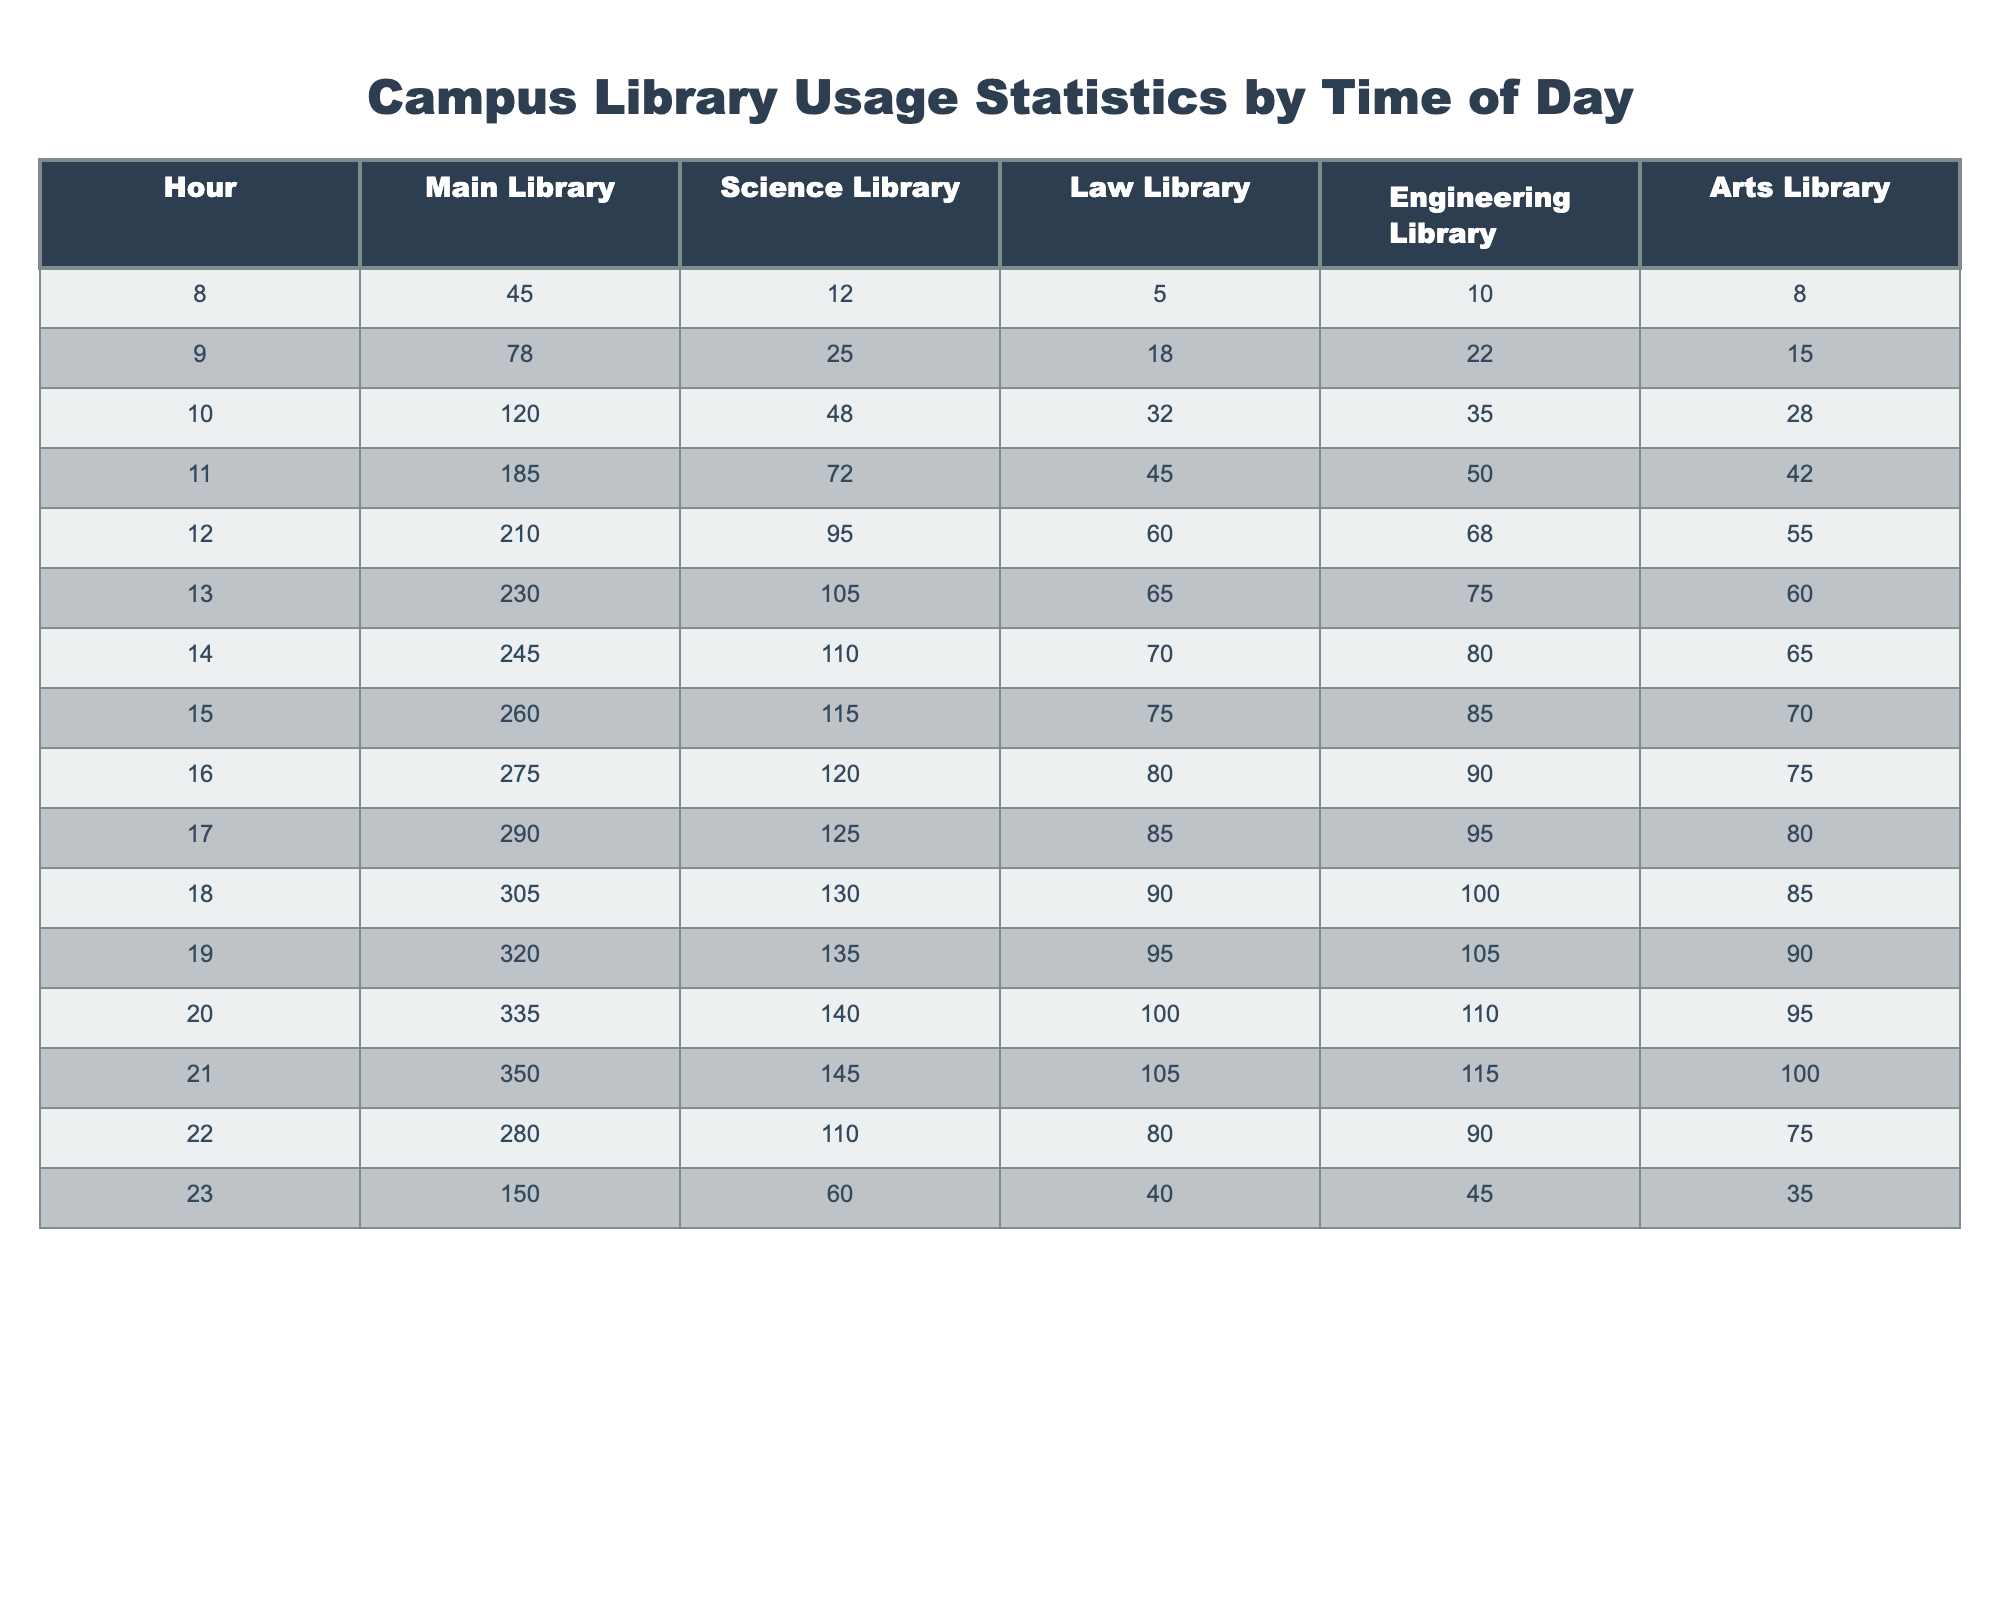What hour had the highest usage in the Main Library? Looking at the Main Library column, the peak value is at hour 21 with 350 users.
Answer: 21 Which library had the least usage at 8 AM? At 8 AM, the Arts Library had the least usage with 8 users compared to the other libraries.
Answer: Arts Library What is the average usage across all libraries at noon? Adding the library usages at noon: 210 (Main) + 95 (Science) + 60 (Law) + 68 (Engineering) + 55 (Arts) = 488. There are 5 libraries, so the average is 488/5 = 97.6.
Answer: 97.6 Which library shows a consistent increase in usage from 8 AM to 6 PM? From 8 AM to 6 PM, both the Main Library and Science Library show consistent increases, but the Main Library shows a higher increase overall.
Answer: Main Library At what time did the Law Library see the first increase in user numbers? The Law Library started with 5 users at 8 AM, but after that, it increased users starting from 9 AM (to 18 users).
Answer: 9 AM What is the total number of users in the Engineering Library from 8 AM to 12 PM? Adding the Engineering Library usage from 8 AM to 12 PM: 10 + 22 + 35 + 50 + 68 = 185.
Answer: 185 Is there any time of day when the Science Library users fell below 100? Yes, at 8 AM, 12 PM, and 1 PM, the Science Library had users below 100.
Answer: Yes What was the user difference between the Main Library and the Arts Library at 6 PM? At 6 PM, the Main Library had 305 users and the Arts Library had 85 users, so the difference is 305 - 85 = 220.
Answer: 220 How many more users visited the Science Library at 10 AM than at 8 AM? The Science Library had 48 users at 10 AM and 12 users at 8 AM, so the difference is 48 - 12 = 36.
Answer: 36 Which library had the largest drop in usage from the peak hour to the last recorded hour? The Main Library peaked at 350 users at 21:00 and dropped to 280 users at 22:00, showing a drop of 70 users, which is the largest drop among the libraries.
Answer: Main Library 